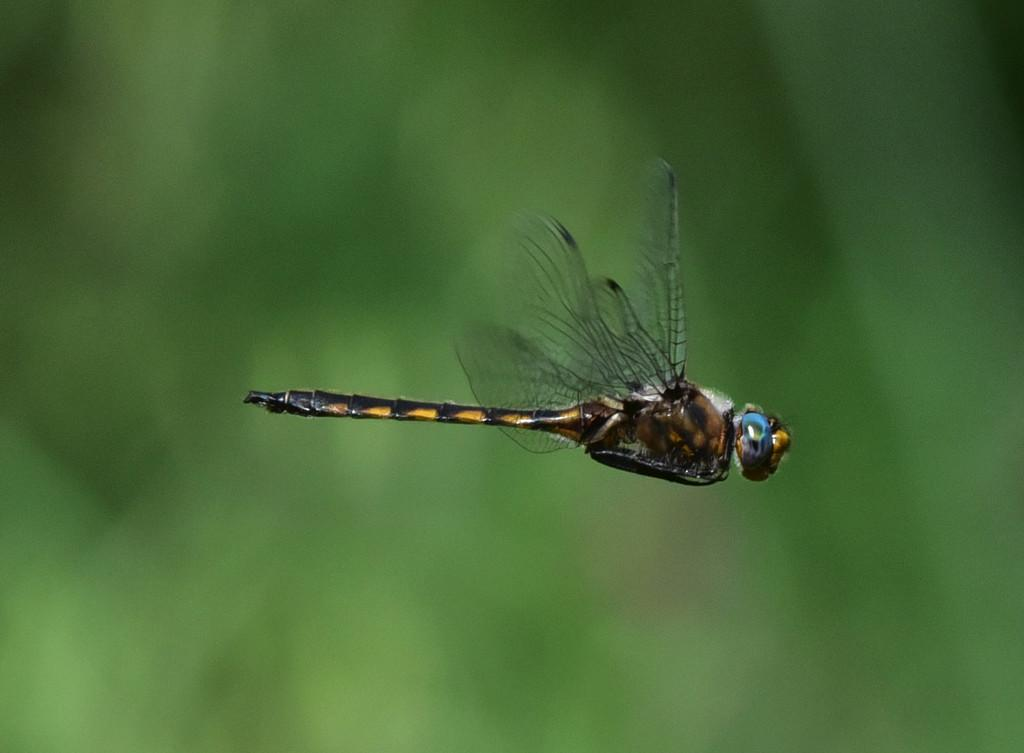What is the main subject in the foreground of the image? There is a dragonfly in the foreground of the image. What can be observed about the background of the image? The background of the image is blurry. What type of shoes is the stranger wearing in the image? There is no stranger present in the image, and therefore no shoes to describe. 